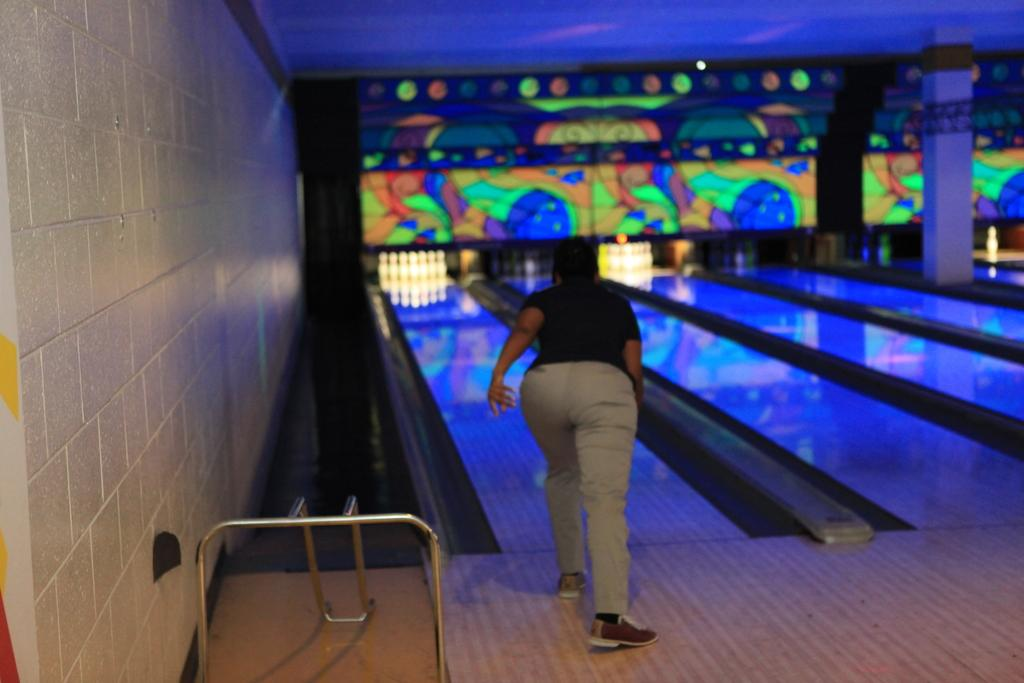What is the main subject of the image? There is a person in the image. What activity is the person engaged in? The person is playing a bowling game in the image. What can be seen in the background of the image? There is a wall and a pillar in the image. What type of surface is the person standing on? There is a floor in the image. What objects are present near the person? There are rods in the image. What shape is the plot of land in the image? There is no plot of land present in the image; it features a person playing a bowling game. What type of border surrounds the image? The image does not have a border; it is a photograph or digital representation of a scene. 